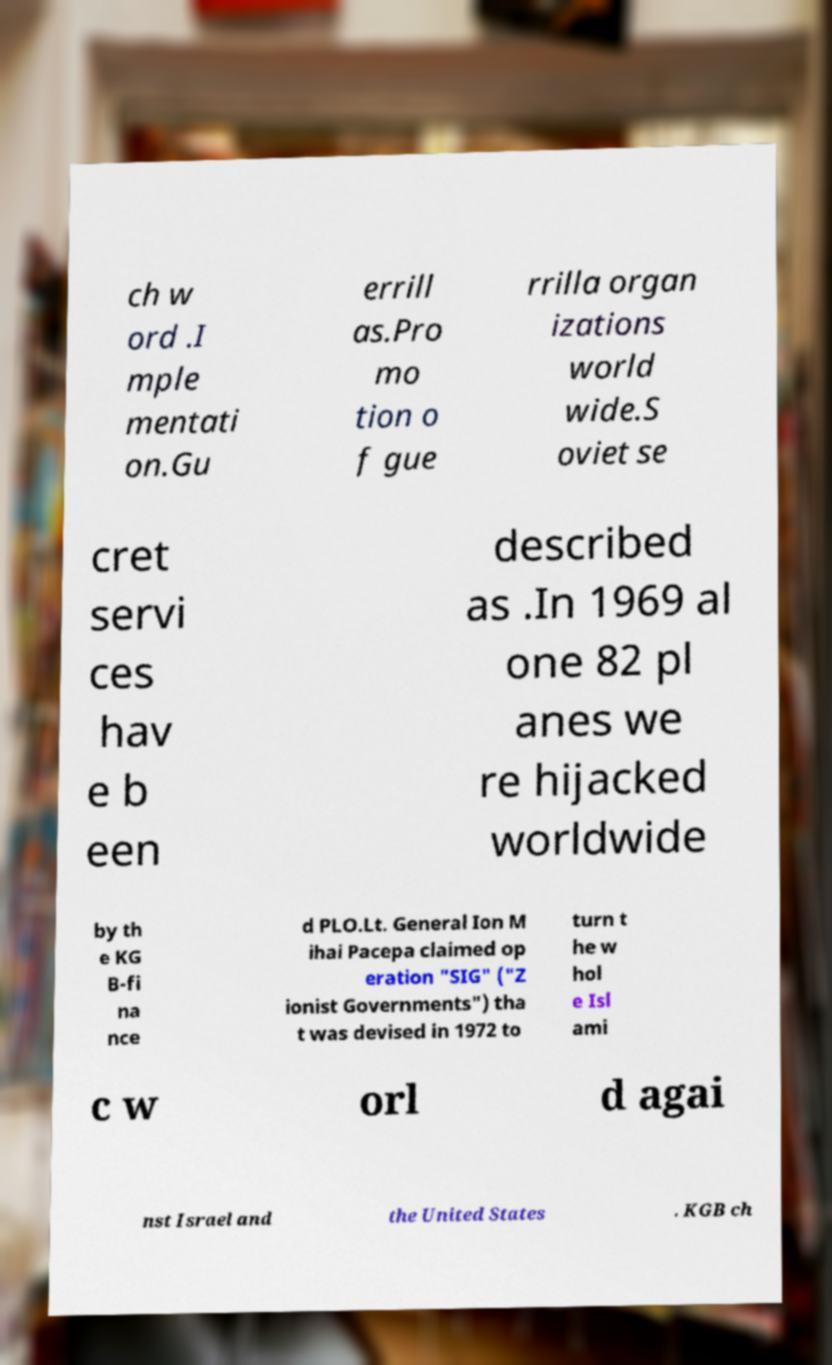Please identify and transcribe the text found in this image. ch w ord .I mple mentati on.Gu errill as.Pro mo tion o f gue rrilla organ izations world wide.S oviet se cret servi ces hav e b een described as .In 1969 al one 82 pl anes we re hijacked worldwide by th e KG B-fi na nce d PLO.Lt. General Ion M ihai Pacepa claimed op eration "SIG" ("Z ionist Governments") tha t was devised in 1972 to turn t he w hol e Isl ami c w orl d agai nst Israel and the United States . KGB ch 